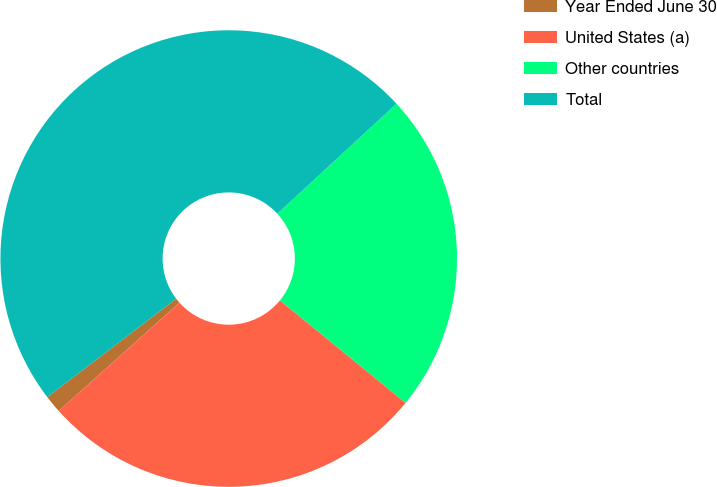<chart> <loc_0><loc_0><loc_500><loc_500><pie_chart><fcel>Year Ended June 30<fcel>United States (a)<fcel>Other countries<fcel>Total<nl><fcel>1.25%<fcel>27.48%<fcel>22.75%<fcel>48.52%<nl></chart> 